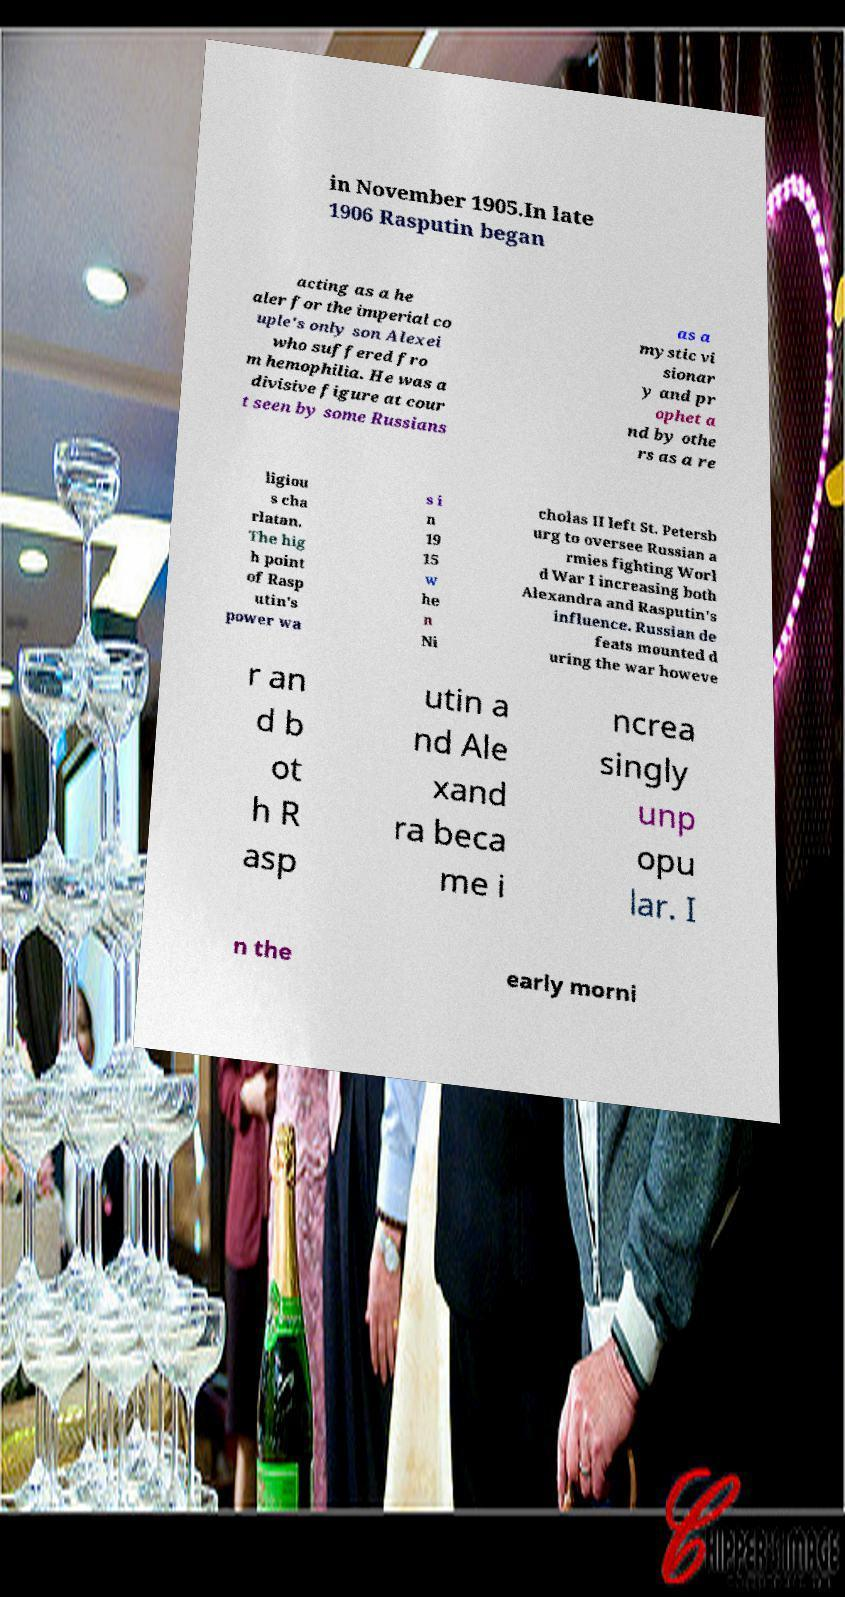Could you assist in decoding the text presented in this image and type it out clearly? in November 1905.In late 1906 Rasputin began acting as a he aler for the imperial co uple's only son Alexei who suffered fro m hemophilia. He was a divisive figure at cour t seen by some Russians as a mystic vi sionar y and pr ophet a nd by othe rs as a re ligiou s cha rlatan. The hig h point of Rasp utin's power wa s i n 19 15 w he n Ni cholas II left St. Petersb urg to oversee Russian a rmies fighting Worl d War I increasing both Alexandra and Rasputin's influence. Russian de feats mounted d uring the war howeve r an d b ot h R asp utin a nd Ale xand ra beca me i ncrea singly unp opu lar. I n the early morni 